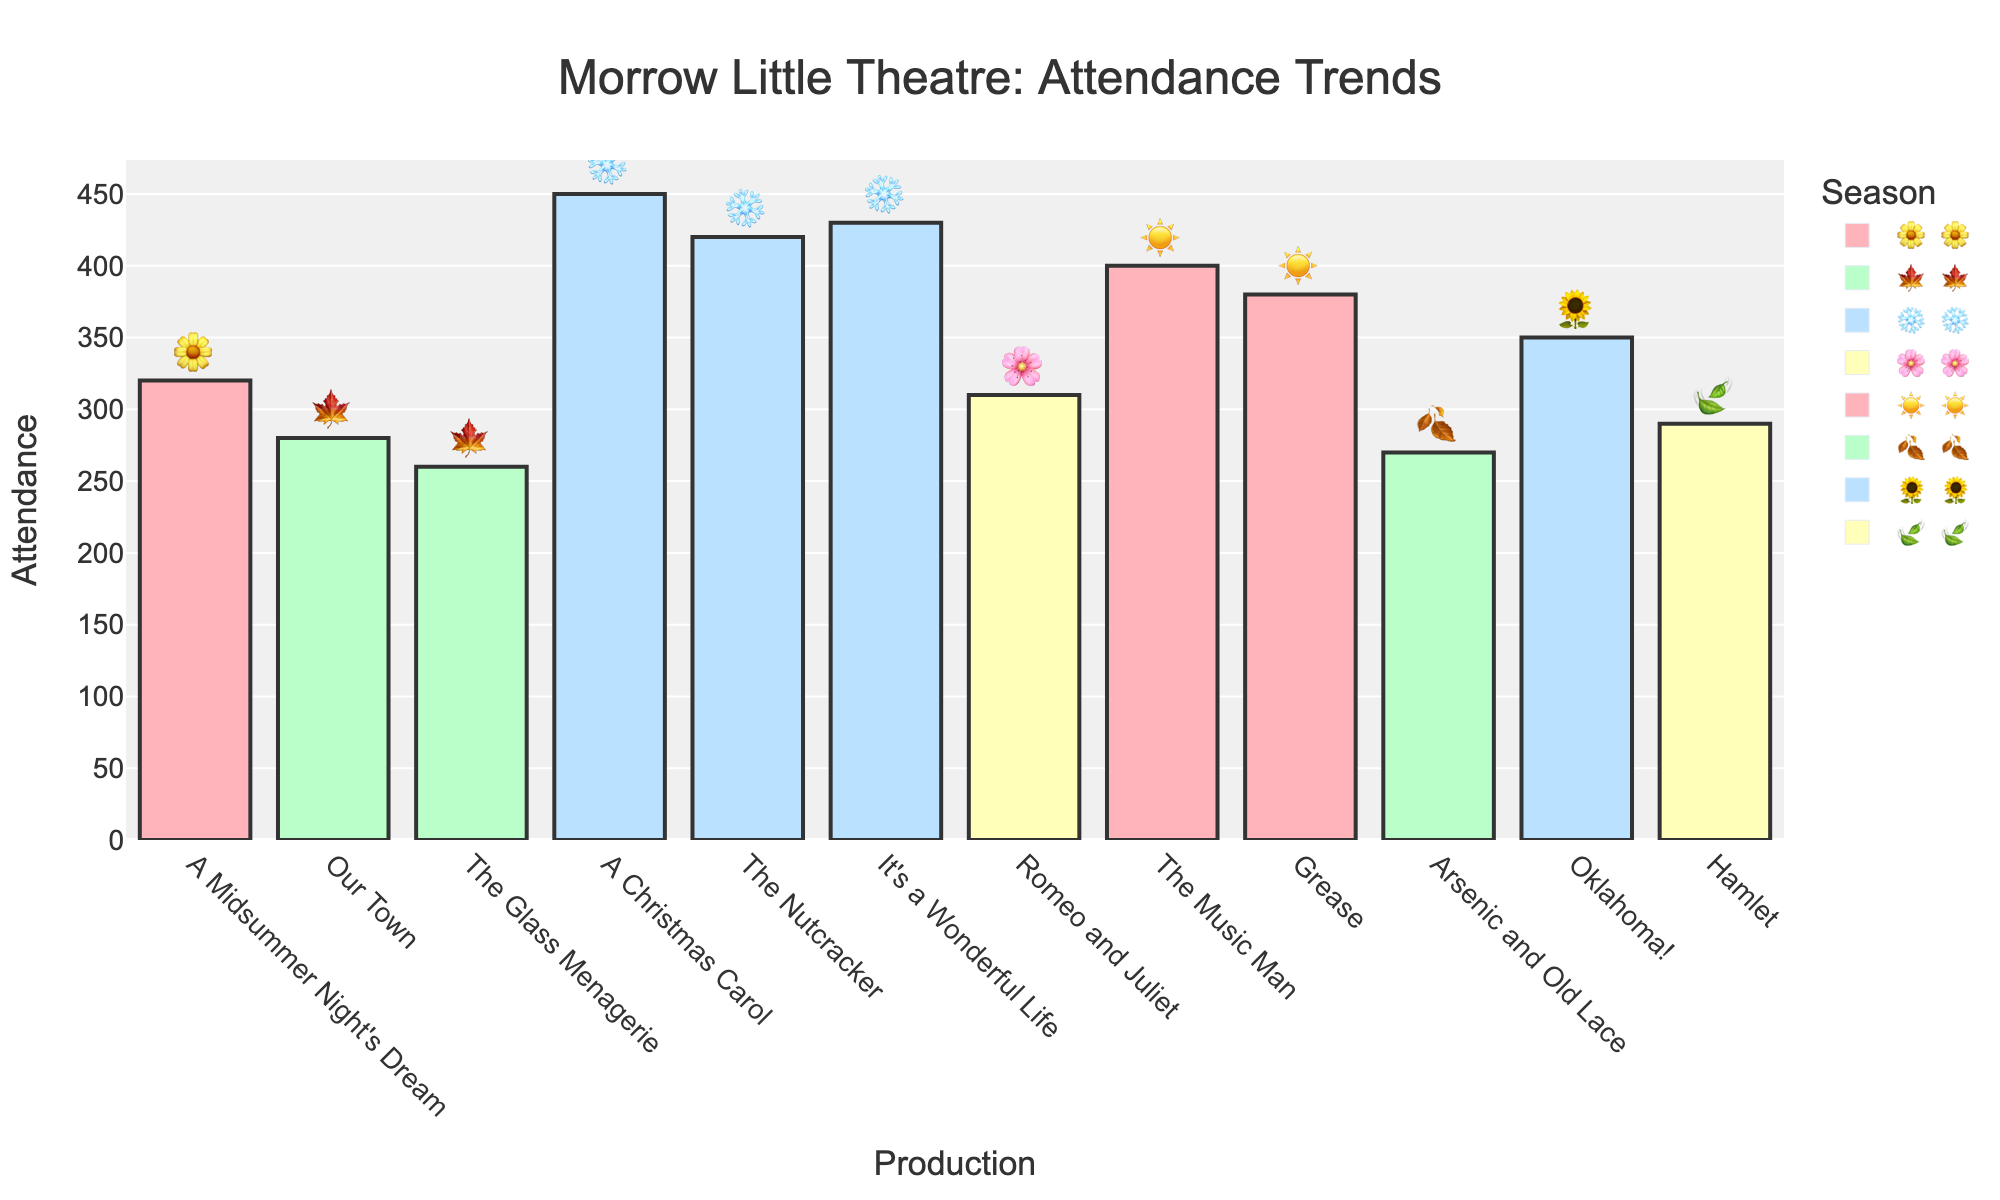What's the title of the chart? The title is prominently displayed at the top of the chart. It reads "Morrow Little Theatre: Attendance Trends."
Answer: Morrow Little Theatre: Attendance Trends Which production had the highest attendance? To determine this, look at each bar and identify the one that reaches the highest value on the Y-axis. "A Christmas Carol" has the highest attendance at 450.
Answer: A Christmas Carol Which season has the most productions? Count the number of bars associated with each season emoji. Winter (❄️) has the most productions with three: "A Christmas Carol," "The Nutcracker," and "It's a Wonderful Life."
Answer: Winter (❄️) What's the attendance difference between "The Music Man" and "Grease"? The attendance for "The Music Man" is 400, and for "Grease," it is 380. The difference is 400 - 380 = 20.
Answer: 20 Which production had the lowest attendance? Look at the height of the bars and identify the shortest one, which corresponds to "The Glass Menagerie" with 260 attendees.
Answer: The Glass Menagerie What's the total attendance for all fall (🍁) productions? Add the attendance numbers for "Our Town" (280) and "The Glass Menagerie" (260). The total is 280 + 260 = 540.
Answer: 540 How many productions have an attendance above 400? Count the number of bars that extend above the 400 mark. There are four productions: "The Music Man" (400), "A Christmas Carol" (450), "The Nutcracker" (420), and "It's a Wonderful Life" (430).
Answer: 4 Which production in summer (☀️) had higher attendance? Compare the two summer productions, "The Music Man" (400) and "Grease" (380). "The Music Man" has the higher attendance.
Answer: The Music Man What is the average attendance for spring (🌸) productions? There are two spring productions: "Romeo and Juliet" (310) and "Oklahoma!" (350). The average is (310 + 350) / 2 = 330.
Answer: 330 